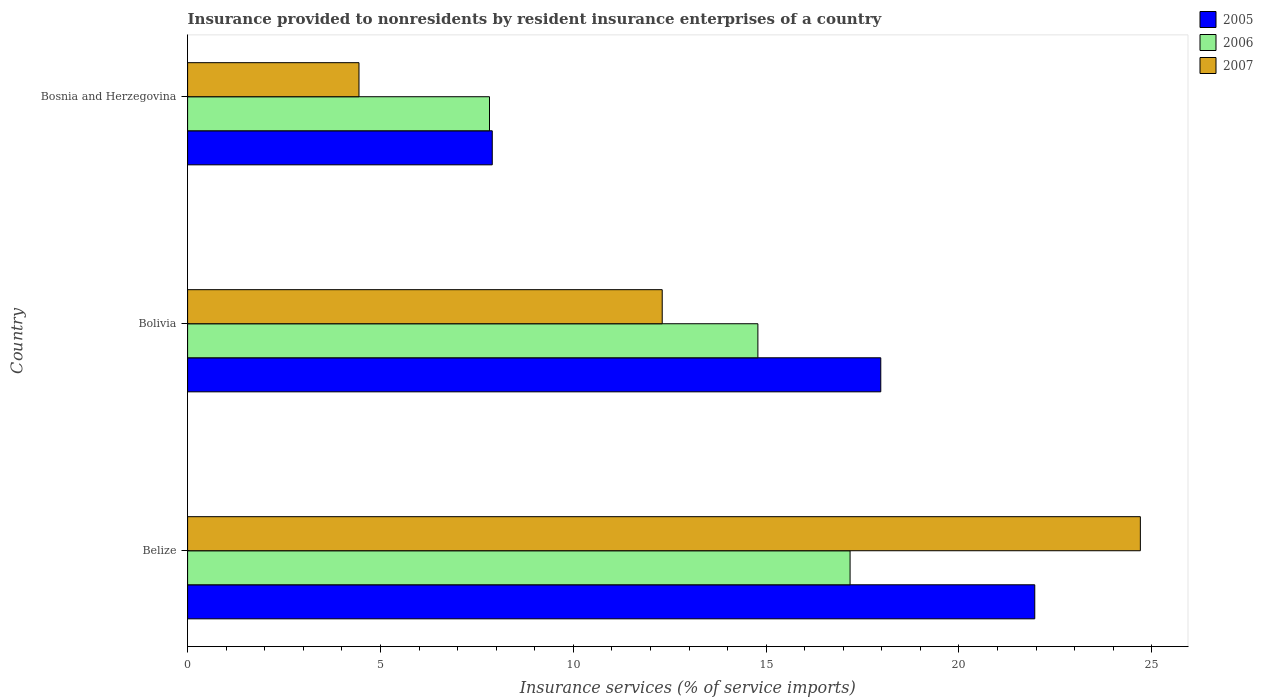Are the number of bars per tick equal to the number of legend labels?
Ensure brevity in your answer.  Yes. How many bars are there on the 1st tick from the top?
Make the answer very short. 3. What is the label of the 2nd group of bars from the top?
Provide a succinct answer. Bolivia. In how many cases, is the number of bars for a given country not equal to the number of legend labels?
Provide a short and direct response. 0. What is the insurance provided to nonresidents in 2007 in Bosnia and Herzegovina?
Offer a very short reply. 4.44. Across all countries, what is the maximum insurance provided to nonresidents in 2007?
Your answer should be compact. 24.7. Across all countries, what is the minimum insurance provided to nonresidents in 2007?
Offer a very short reply. 4.44. In which country was the insurance provided to nonresidents in 2007 maximum?
Your answer should be very brief. Belize. In which country was the insurance provided to nonresidents in 2005 minimum?
Your response must be concise. Bosnia and Herzegovina. What is the total insurance provided to nonresidents in 2005 in the graph?
Make the answer very short. 47.84. What is the difference between the insurance provided to nonresidents in 2007 in Bolivia and that in Bosnia and Herzegovina?
Offer a terse response. 7.86. What is the difference between the insurance provided to nonresidents in 2007 in Belize and the insurance provided to nonresidents in 2005 in Bosnia and Herzegovina?
Keep it short and to the point. 16.8. What is the average insurance provided to nonresidents in 2006 per country?
Provide a succinct answer. 13.26. What is the difference between the insurance provided to nonresidents in 2006 and insurance provided to nonresidents in 2007 in Bosnia and Herzegovina?
Ensure brevity in your answer.  3.38. In how many countries, is the insurance provided to nonresidents in 2007 greater than 22 %?
Your answer should be very brief. 1. What is the ratio of the insurance provided to nonresidents in 2005 in Bolivia to that in Bosnia and Herzegovina?
Offer a terse response. 2.28. Is the insurance provided to nonresidents in 2005 in Belize less than that in Bosnia and Herzegovina?
Ensure brevity in your answer.  No. Is the difference between the insurance provided to nonresidents in 2006 in Belize and Bolivia greater than the difference between the insurance provided to nonresidents in 2007 in Belize and Bolivia?
Ensure brevity in your answer.  No. What is the difference between the highest and the second highest insurance provided to nonresidents in 2006?
Your answer should be compact. 2.39. What is the difference between the highest and the lowest insurance provided to nonresidents in 2005?
Keep it short and to the point. 14.07. How many bars are there?
Your answer should be very brief. 9. Are all the bars in the graph horizontal?
Offer a very short reply. Yes. How many countries are there in the graph?
Ensure brevity in your answer.  3. Are the values on the major ticks of X-axis written in scientific E-notation?
Your answer should be very brief. No. Does the graph contain grids?
Offer a terse response. No. How many legend labels are there?
Offer a very short reply. 3. How are the legend labels stacked?
Keep it short and to the point. Vertical. What is the title of the graph?
Ensure brevity in your answer.  Insurance provided to nonresidents by resident insurance enterprises of a country. What is the label or title of the X-axis?
Make the answer very short. Insurance services (% of service imports). What is the label or title of the Y-axis?
Offer a terse response. Country. What is the Insurance services (% of service imports) of 2005 in Belize?
Provide a short and direct response. 21.96. What is the Insurance services (% of service imports) in 2006 in Belize?
Give a very brief answer. 17.18. What is the Insurance services (% of service imports) of 2007 in Belize?
Give a very brief answer. 24.7. What is the Insurance services (% of service imports) in 2005 in Bolivia?
Keep it short and to the point. 17.97. What is the Insurance services (% of service imports) of 2006 in Bolivia?
Provide a short and direct response. 14.79. What is the Insurance services (% of service imports) in 2007 in Bolivia?
Your response must be concise. 12.31. What is the Insurance services (% of service imports) in 2005 in Bosnia and Herzegovina?
Ensure brevity in your answer.  7.9. What is the Insurance services (% of service imports) in 2006 in Bosnia and Herzegovina?
Provide a succinct answer. 7.83. What is the Insurance services (% of service imports) in 2007 in Bosnia and Herzegovina?
Provide a short and direct response. 4.44. Across all countries, what is the maximum Insurance services (% of service imports) in 2005?
Your answer should be compact. 21.96. Across all countries, what is the maximum Insurance services (% of service imports) in 2006?
Offer a terse response. 17.18. Across all countries, what is the maximum Insurance services (% of service imports) in 2007?
Your answer should be compact. 24.7. Across all countries, what is the minimum Insurance services (% of service imports) in 2005?
Make the answer very short. 7.9. Across all countries, what is the minimum Insurance services (% of service imports) of 2006?
Your response must be concise. 7.83. Across all countries, what is the minimum Insurance services (% of service imports) of 2007?
Your answer should be very brief. 4.44. What is the total Insurance services (% of service imports) of 2005 in the graph?
Provide a short and direct response. 47.84. What is the total Insurance services (% of service imports) of 2006 in the graph?
Your answer should be very brief. 39.79. What is the total Insurance services (% of service imports) of 2007 in the graph?
Your response must be concise. 41.45. What is the difference between the Insurance services (% of service imports) of 2005 in Belize and that in Bolivia?
Your answer should be very brief. 3.99. What is the difference between the Insurance services (% of service imports) of 2006 in Belize and that in Bolivia?
Ensure brevity in your answer.  2.39. What is the difference between the Insurance services (% of service imports) of 2007 in Belize and that in Bolivia?
Make the answer very short. 12.4. What is the difference between the Insurance services (% of service imports) of 2005 in Belize and that in Bosnia and Herzegovina?
Your answer should be very brief. 14.07. What is the difference between the Insurance services (% of service imports) in 2006 in Belize and that in Bosnia and Herzegovina?
Give a very brief answer. 9.35. What is the difference between the Insurance services (% of service imports) in 2007 in Belize and that in Bosnia and Herzegovina?
Give a very brief answer. 20.26. What is the difference between the Insurance services (% of service imports) in 2005 in Bolivia and that in Bosnia and Herzegovina?
Your answer should be very brief. 10.07. What is the difference between the Insurance services (% of service imports) in 2006 in Bolivia and that in Bosnia and Herzegovina?
Your answer should be compact. 6.96. What is the difference between the Insurance services (% of service imports) in 2007 in Bolivia and that in Bosnia and Herzegovina?
Give a very brief answer. 7.86. What is the difference between the Insurance services (% of service imports) of 2005 in Belize and the Insurance services (% of service imports) of 2006 in Bolivia?
Offer a very short reply. 7.18. What is the difference between the Insurance services (% of service imports) in 2005 in Belize and the Insurance services (% of service imports) in 2007 in Bolivia?
Your answer should be compact. 9.66. What is the difference between the Insurance services (% of service imports) of 2006 in Belize and the Insurance services (% of service imports) of 2007 in Bolivia?
Keep it short and to the point. 4.87. What is the difference between the Insurance services (% of service imports) of 2005 in Belize and the Insurance services (% of service imports) of 2006 in Bosnia and Herzegovina?
Your answer should be very brief. 14.14. What is the difference between the Insurance services (% of service imports) in 2005 in Belize and the Insurance services (% of service imports) in 2007 in Bosnia and Herzegovina?
Provide a succinct answer. 17.52. What is the difference between the Insurance services (% of service imports) of 2006 in Belize and the Insurance services (% of service imports) of 2007 in Bosnia and Herzegovina?
Your answer should be compact. 12.73. What is the difference between the Insurance services (% of service imports) of 2005 in Bolivia and the Insurance services (% of service imports) of 2006 in Bosnia and Herzegovina?
Provide a succinct answer. 10.15. What is the difference between the Insurance services (% of service imports) in 2005 in Bolivia and the Insurance services (% of service imports) in 2007 in Bosnia and Herzegovina?
Provide a succinct answer. 13.53. What is the difference between the Insurance services (% of service imports) in 2006 in Bolivia and the Insurance services (% of service imports) in 2007 in Bosnia and Herzegovina?
Offer a very short reply. 10.34. What is the average Insurance services (% of service imports) of 2005 per country?
Your answer should be very brief. 15.95. What is the average Insurance services (% of service imports) of 2006 per country?
Make the answer very short. 13.26. What is the average Insurance services (% of service imports) of 2007 per country?
Offer a terse response. 13.82. What is the difference between the Insurance services (% of service imports) in 2005 and Insurance services (% of service imports) in 2006 in Belize?
Give a very brief answer. 4.79. What is the difference between the Insurance services (% of service imports) of 2005 and Insurance services (% of service imports) of 2007 in Belize?
Your answer should be compact. -2.74. What is the difference between the Insurance services (% of service imports) in 2006 and Insurance services (% of service imports) in 2007 in Belize?
Offer a very short reply. -7.53. What is the difference between the Insurance services (% of service imports) in 2005 and Insurance services (% of service imports) in 2006 in Bolivia?
Provide a short and direct response. 3.19. What is the difference between the Insurance services (% of service imports) of 2005 and Insurance services (% of service imports) of 2007 in Bolivia?
Ensure brevity in your answer.  5.67. What is the difference between the Insurance services (% of service imports) in 2006 and Insurance services (% of service imports) in 2007 in Bolivia?
Give a very brief answer. 2.48. What is the difference between the Insurance services (% of service imports) in 2005 and Insurance services (% of service imports) in 2006 in Bosnia and Herzegovina?
Make the answer very short. 0.07. What is the difference between the Insurance services (% of service imports) of 2005 and Insurance services (% of service imports) of 2007 in Bosnia and Herzegovina?
Provide a short and direct response. 3.46. What is the difference between the Insurance services (% of service imports) in 2006 and Insurance services (% of service imports) in 2007 in Bosnia and Herzegovina?
Make the answer very short. 3.38. What is the ratio of the Insurance services (% of service imports) of 2005 in Belize to that in Bolivia?
Give a very brief answer. 1.22. What is the ratio of the Insurance services (% of service imports) in 2006 in Belize to that in Bolivia?
Your response must be concise. 1.16. What is the ratio of the Insurance services (% of service imports) in 2007 in Belize to that in Bolivia?
Your response must be concise. 2.01. What is the ratio of the Insurance services (% of service imports) in 2005 in Belize to that in Bosnia and Herzegovina?
Provide a short and direct response. 2.78. What is the ratio of the Insurance services (% of service imports) of 2006 in Belize to that in Bosnia and Herzegovina?
Give a very brief answer. 2.19. What is the ratio of the Insurance services (% of service imports) of 2007 in Belize to that in Bosnia and Herzegovina?
Your answer should be compact. 5.56. What is the ratio of the Insurance services (% of service imports) in 2005 in Bolivia to that in Bosnia and Herzegovina?
Your answer should be very brief. 2.28. What is the ratio of the Insurance services (% of service imports) in 2006 in Bolivia to that in Bosnia and Herzegovina?
Provide a short and direct response. 1.89. What is the ratio of the Insurance services (% of service imports) in 2007 in Bolivia to that in Bosnia and Herzegovina?
Give a very brief answer. 2.77. What is the difference between the highest and the second highest Insurance services (% of service imports) of 2005?
Give a very brief answer. 3.99. What is the difference between the highest and the second highest Insurance services (% of service imports) of 2006?
Keep it short and to the point. 2.39. What is the difference between the highest and the second highest Insurance services (% of service imports) in 2007?
Provide a succinct answer. 12.4. What is the difference between the highest and the lowest Insurance services (% of service imports) of 2005?
Offer a terse response. 14.07. What is the difference between the highest and the lowest Insurance services (% of service imports) in 2006?
Keep it short and to the point. 9.35. What is the difference between the highest and the lowest Insurance services (% of service imports) of 2007?
Keep it short and to the point. 20.26. 